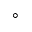Convert formula to latex. <formula><loc_0><loc_0><loc_500><loc_500>^ { \circ }</formula> 